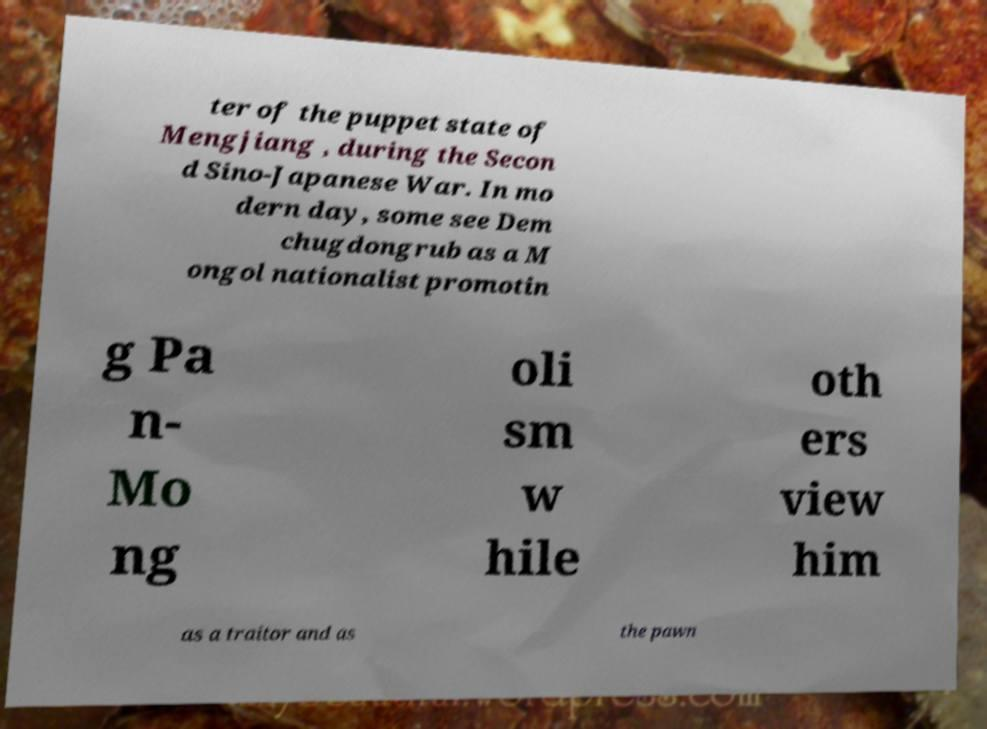What messages or text are displayed in this image? I need them in a readable, typed format. ter of the puppet state of Mengjiang , during the Secon d Sino-Japanese War. In mo dern day, some see Dem chugdongrub as a M ongol nationalist promotin g Pa n- Mo ng oli sm w hile oth ers view him as a traitor and as the pawn 